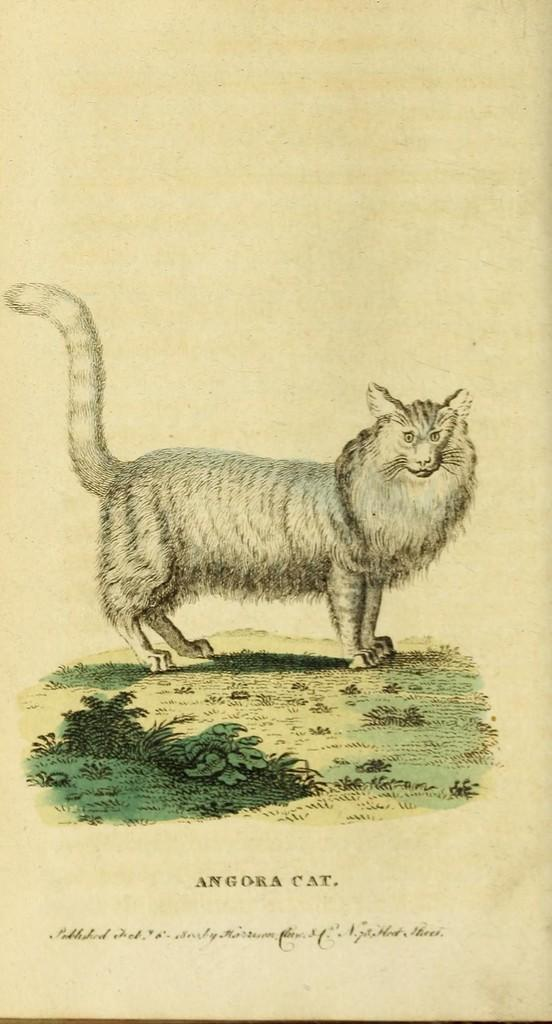What is present on the paper in the image? There is a paper in the image. What can be found on the paper? There are words on the paper. What else is depicted on the paper? There is an image of an animal on the paper. What type of map is shown on the paper in the image? There is no map present on the paper in the image; it features words and an image of an animal. How many matches are visible on the paper in the image? There are no matches present on the paper in the image. 